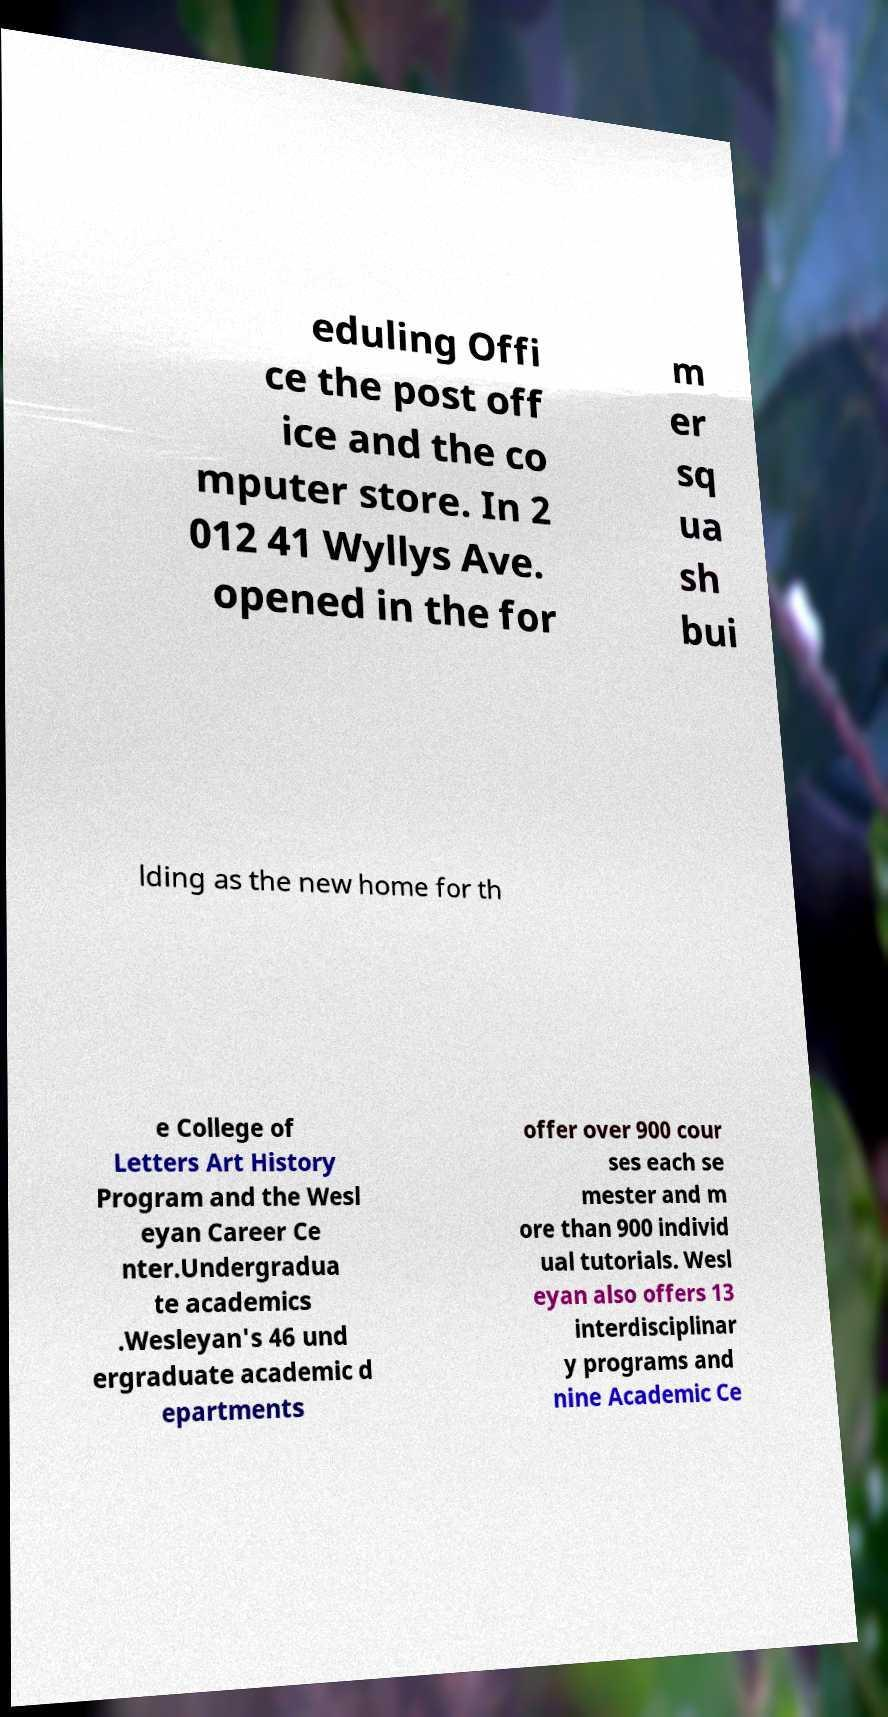Could you extract and type out the text from this image? eduling Offi ce the post off ice and the co mputer store. In 2 012 41 Wyllys Ave. opened in the for m er sq ua sh bui lding as the new home for th e College of Letters Art History Program and the Wesl eyan Career Ce nter.Undergradua te academics .Wesleyan's 46 und ergraduate academic d epartments offer over 900 cour ses each se mester and m ore than 900 individ ual tutorials. Wesl eyan also offers 13 interdisciplinar y programs and nine Academic Ce 